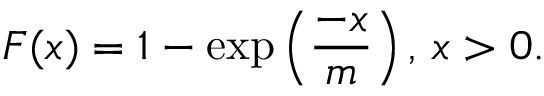<formula> <loc_0><loc_0><loc_500><loc_500>F ( x ) = 1 - \exp \left ( \frac { - x } { m } \right ) , \, x > 0 .</formula> 